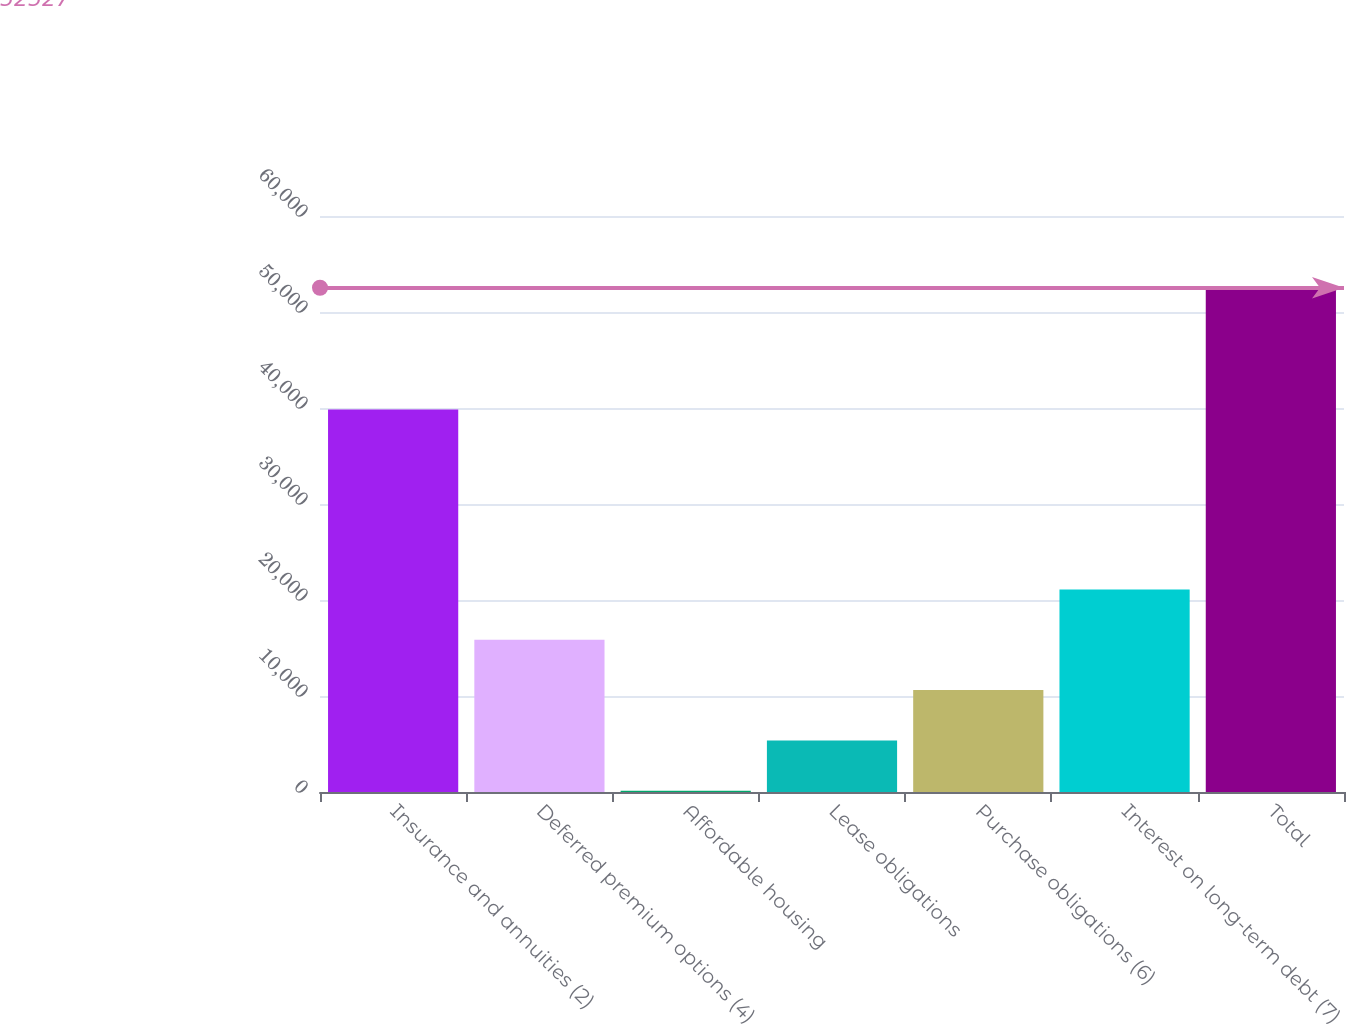Convert chart to OTSL. <chart><loc_0><loc_0><loc_500><loc_500><bar_chart><fcel>Insurance and annuities (2)<fcel>Deferred premium options (4)<fcel>Affordable housing<fcel>Lease obligations<fcel>Purchase obligations (6)<fcel>Interest on long-term debt (7)<fcel>Total<nl><fcel>39849<fcel>15854<fcel>137<fcel>5376<fcel>10615<fcel>21093<fcel>52527<nl></chart> 